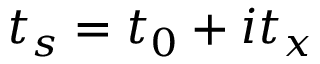<formula> <loc_0><loc_0><loc_500><loc_500>t _ { s } = t _ { 0 } + i t _ { x }</formula> 